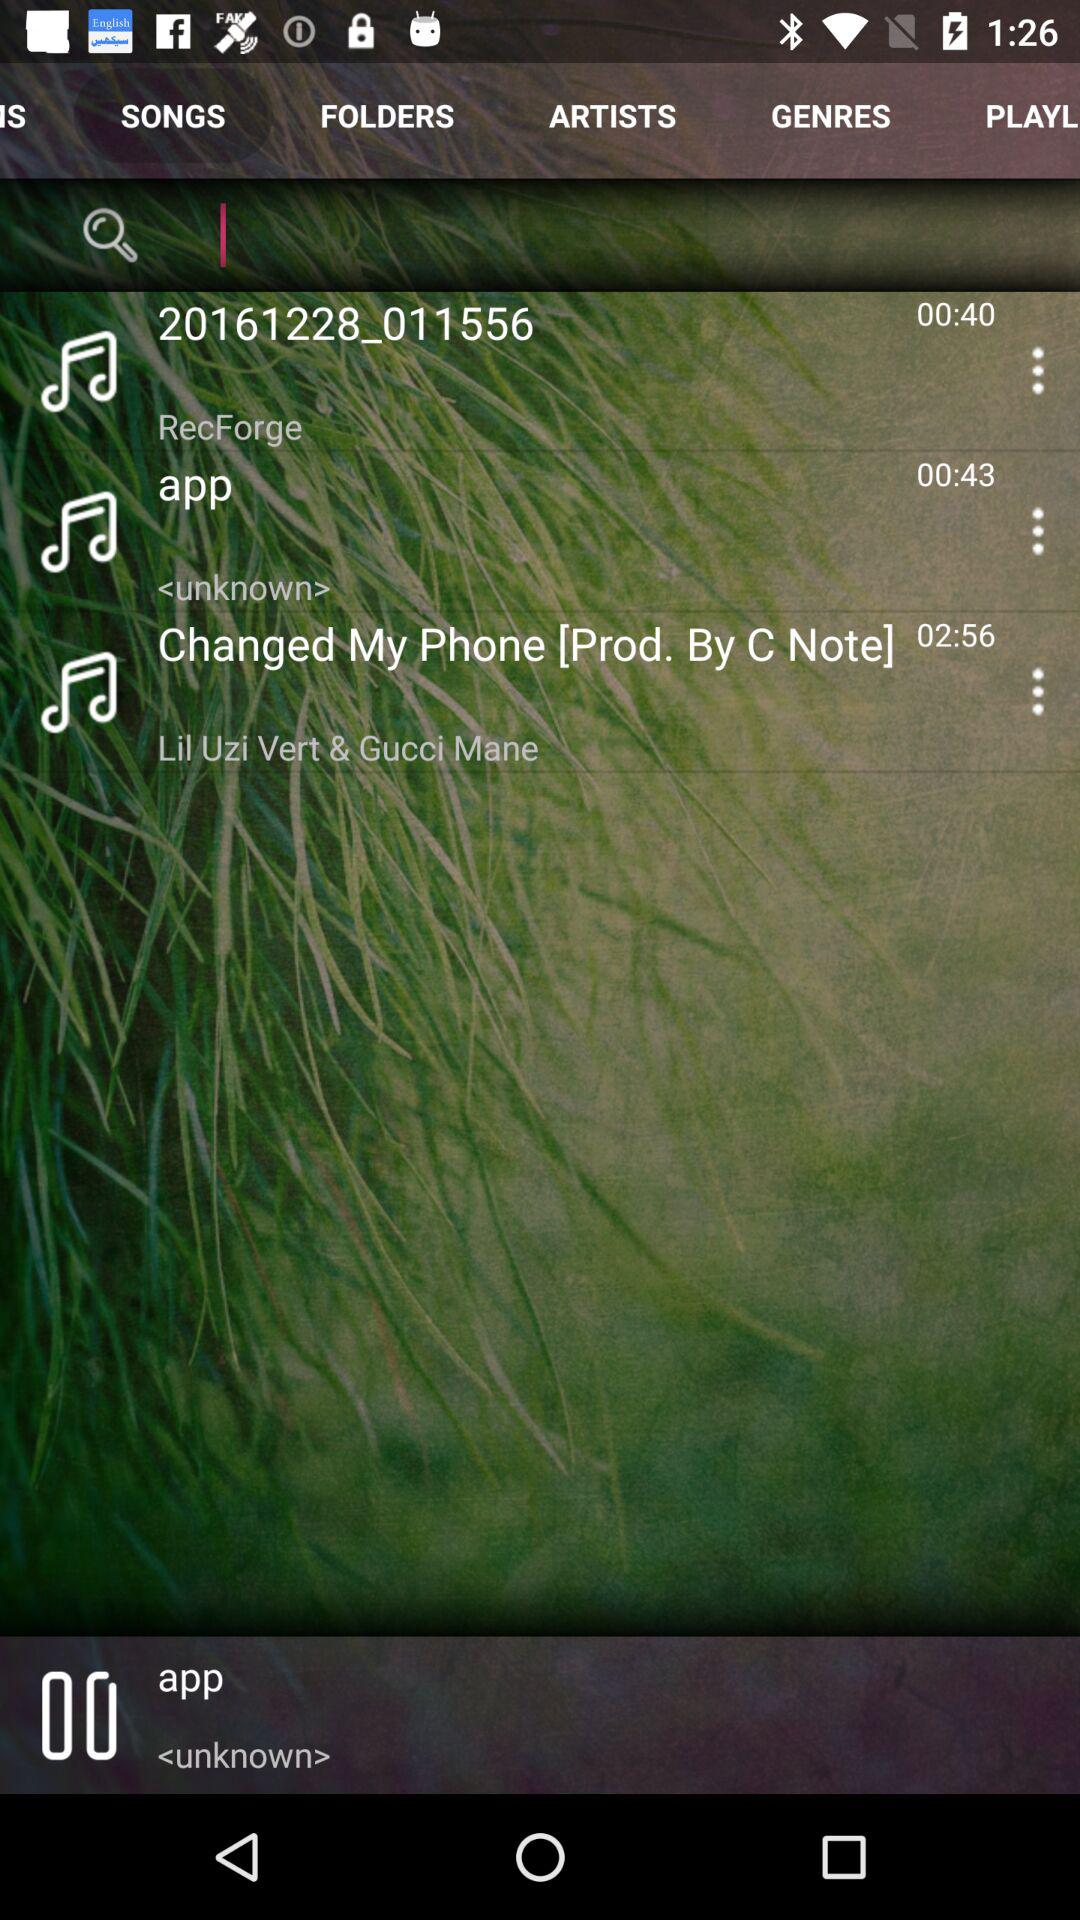Which tab is selected?
When the provided information is insufficient, respond with <no answer>. <no answer> 